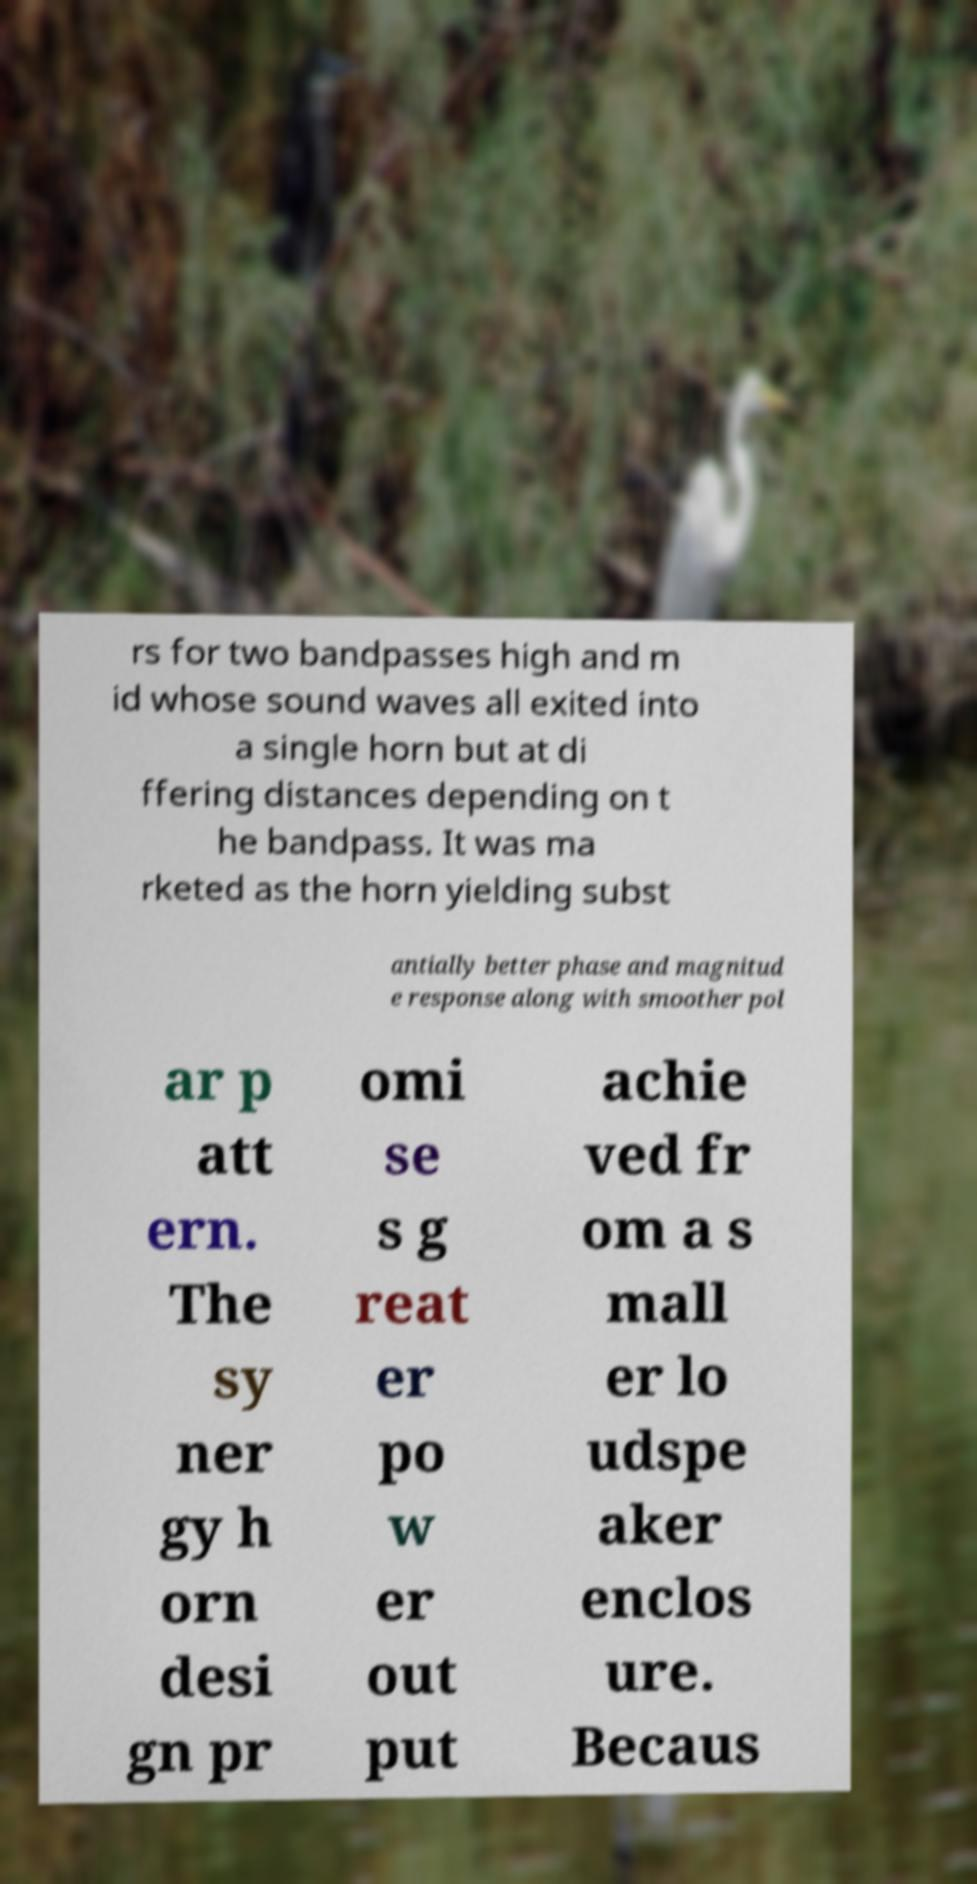For documentation purposes, I need the text within this image transcribed. Could you provide that? rs for two bandpasses high and m id whose sound waves all exited into a single horn but at di ffering distances depending on t he bandpass. It was ma rketed as the horn yielding subst antially better phase and magnitud e response along with smoother pol ar p att ern. The sy ner gy h orn desi gn pr omi se s g reat er po w er out put achie ved fr om a s mall er lo udspe aker enclos ure. Becaus 